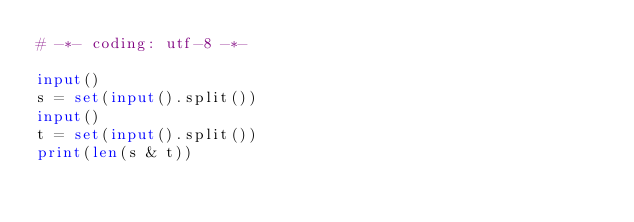<code> <loc_0><loc_0><loc_500><loc_500><_Python_># -*- coding: utf-8 -*-

input()
s = set(input().split())
input()
t = set(input().split())
print(len(s & t))
</code> 